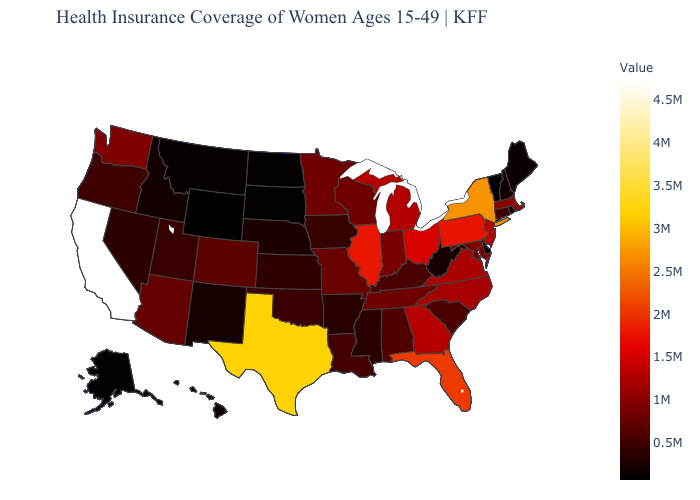Which states have the lowest value in the USA?
Answer briefly. Wyoming. Does Wyoming have the lowest value in the USA?
Answer briefly. Yes. Is the legend a continuous bar?
Be succinct. Yes. Among the states that border Wyoming , which have the lowest value?
Write a very short answer. South Dakota. Does Delaware have the lowest value in the South?
Concise answer only. Yes. Among the states that border Ohio , does Pennsylvania have the highest value?
Answer briefly. Yes. 